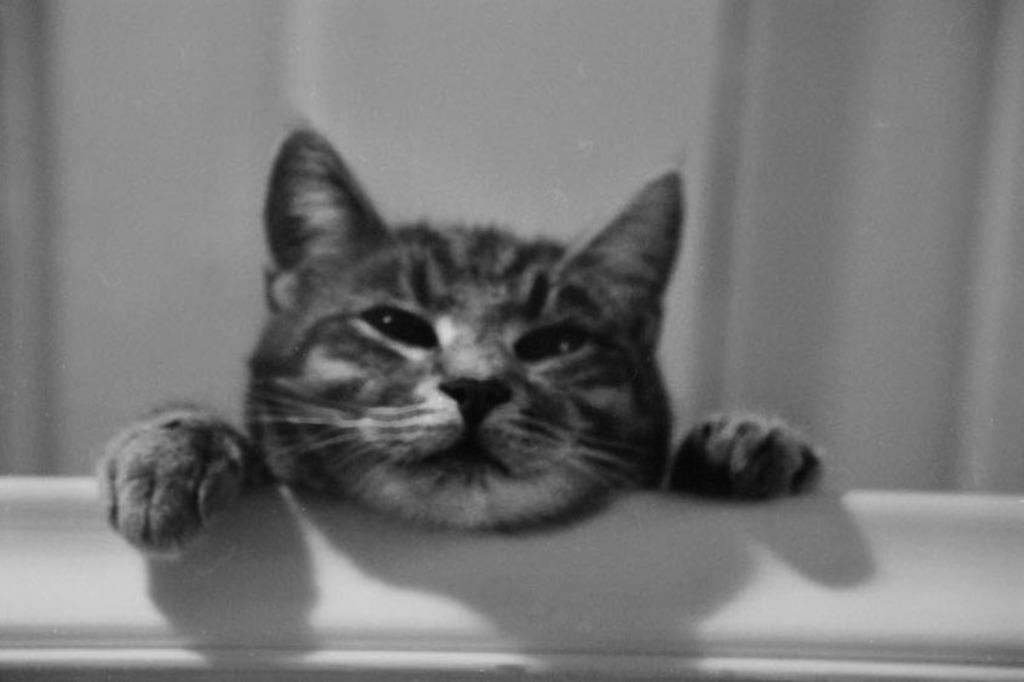How would you summarize this image in a sentence or two? In this image I can see the black and white picture in which I can see a cat. I can see the white colored background. 